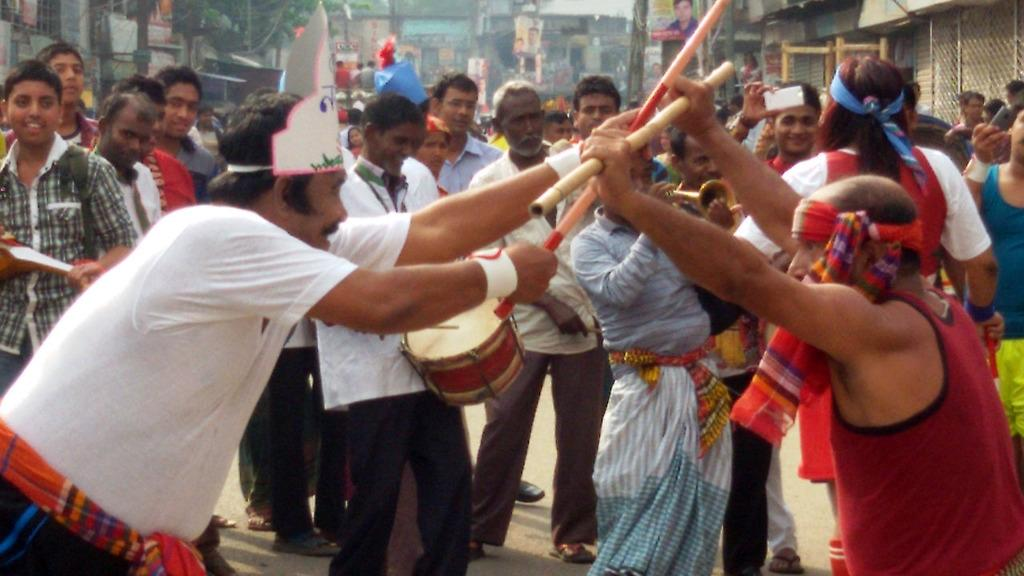What are the people in the image doing? The people in the image are dancing with sticks. Where is the dancing taking place? The dancing is taking place on the road. Are there any observers in the image? Yes, there are spectators behind the dancers. What can be seen in the background of the image? There are buildings, trees, banners, and poles visible in the background of the image. How many horses are participating in the dance in the image? There are no horses present in the image; the people are dancing with sticks. What type of trouble is the dancer facing in the image? There is no indication of trouble in the image; the people are simply dancing with sticks. 